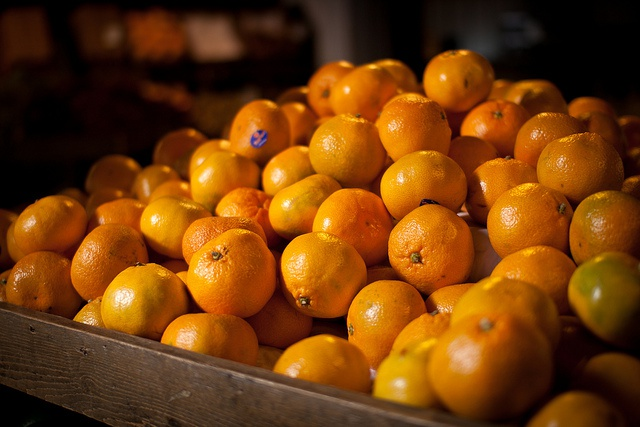Describe the objects in this image and their specific colors. I can see orange in black, maroon, brown, and orange tones, orange in black, maroon, brown, and orange tones, orange in black, red, orange, and brown tones, orange in black, brown, orange, and maroon tones, and orange in black, orange, maroon, and brown tones in this image. 